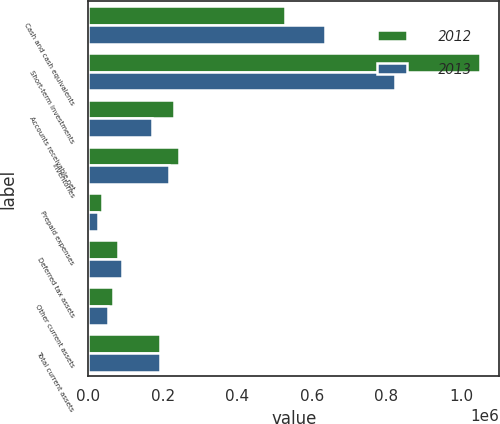<chart> <loc_0><loc_0><loc_500><loc_500><stacked_bar_chart><ecel><fcel>Cash and cash equivalents<fcel>Short-term investments<fcel>Accounts receivable net<fcel>Inventories<fcel>Prepaid expenses<fcel>Deferred tax assets<fcel>Other current assets<fcel>Total current assets<nl><fcel>2012<fcel>528334<fcel>1.05026e+06<fcel>229955<fcel>242334<fcel>37439<fcel>80687<fcel>67358<fcel>193740<nl><fcel>2013<fcel>635755<fcel>823254<fcel>170201<fcel>217278<fcel>25658<fcel>91191<fcel>52524<fcel>193740<nl></chart> 